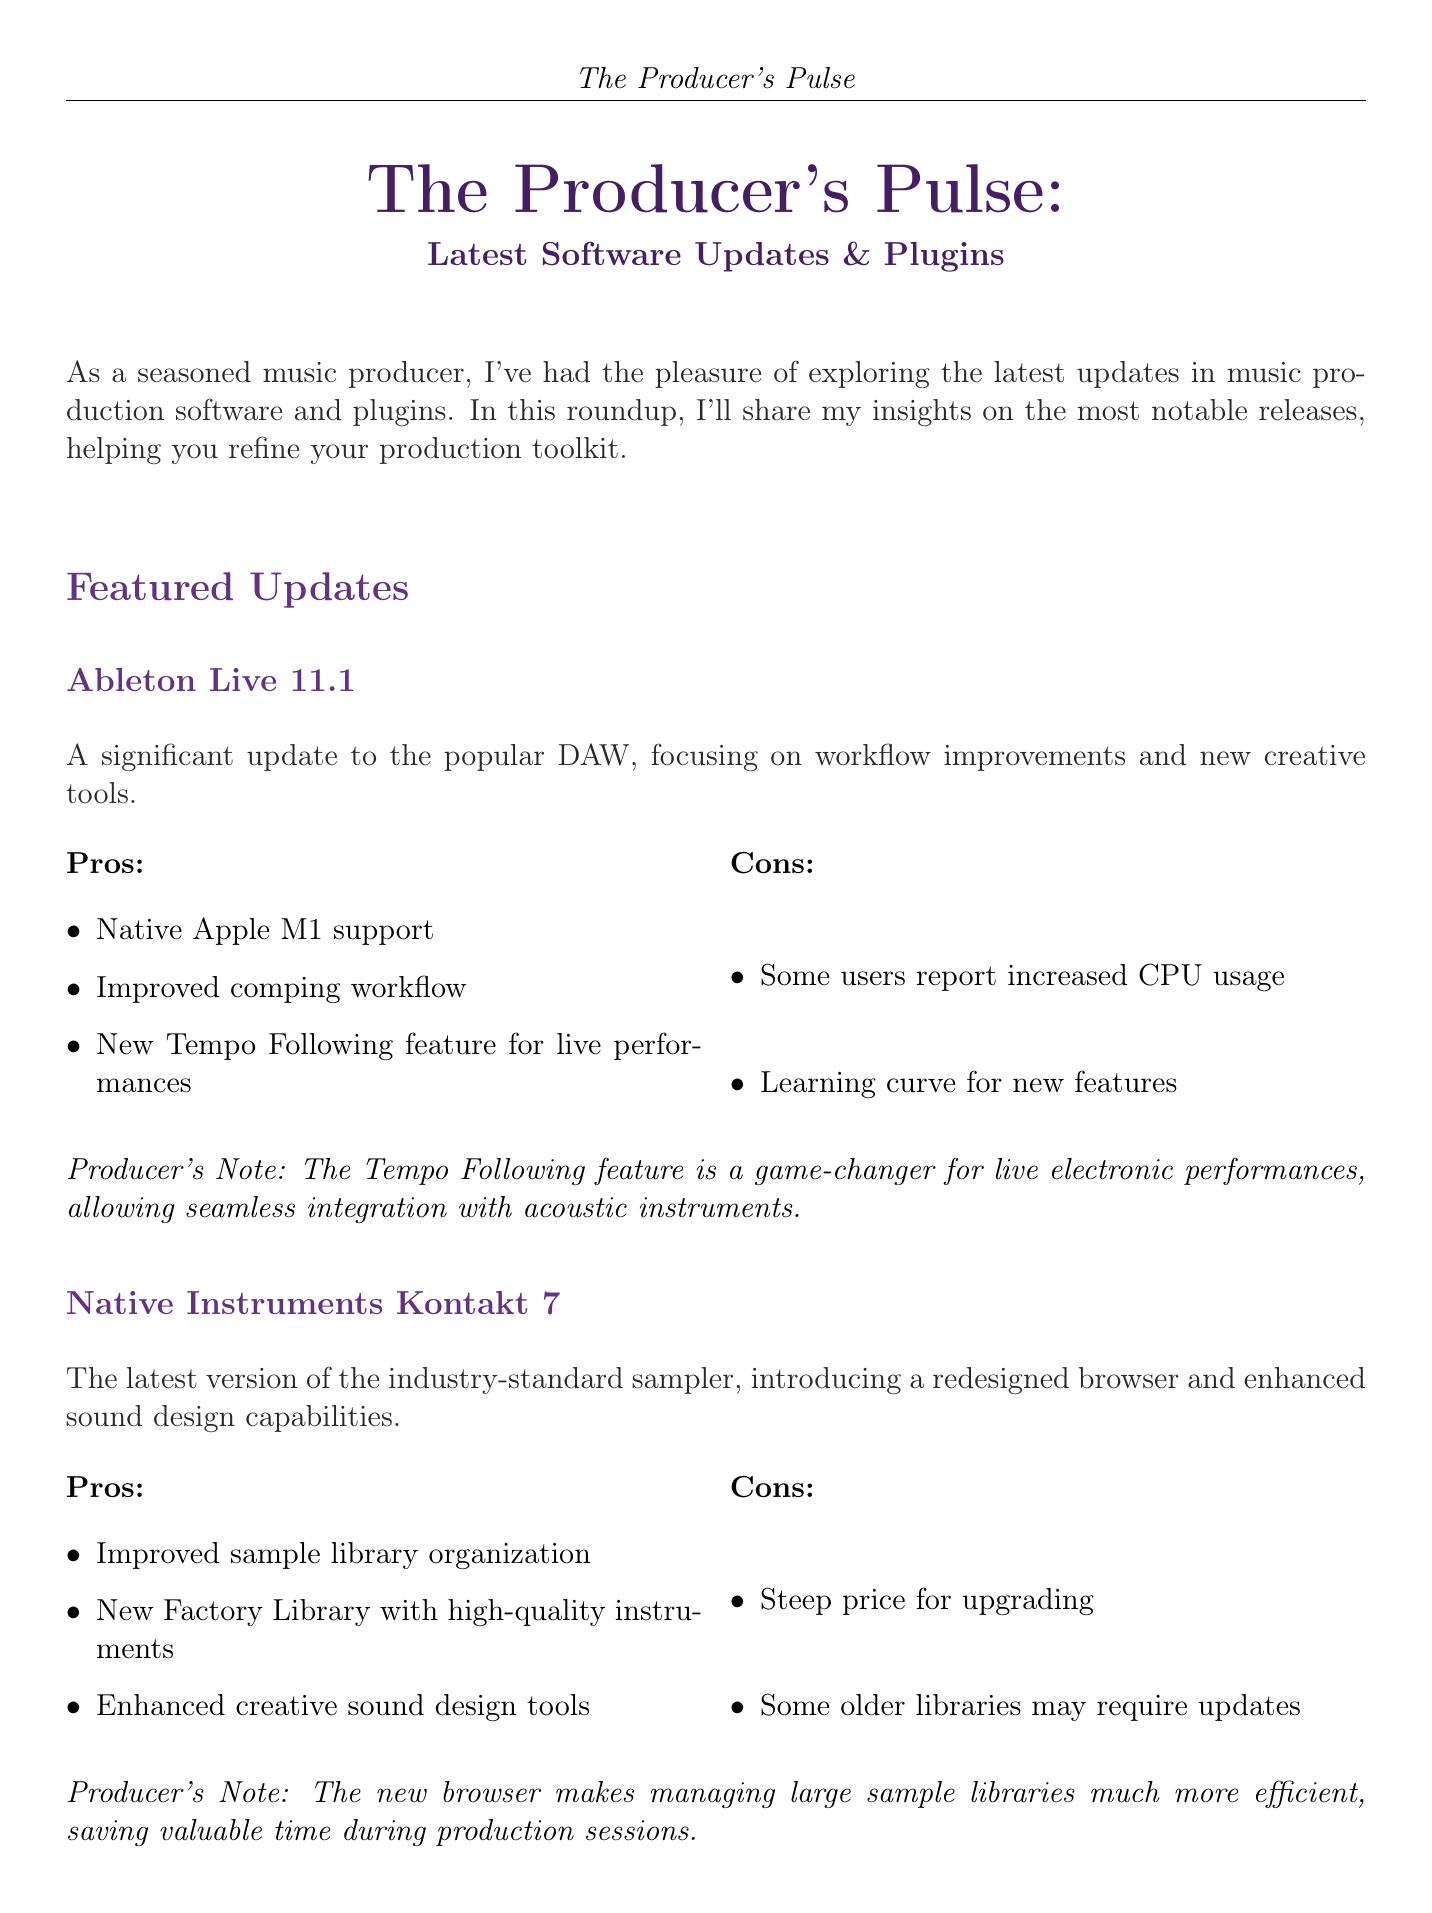What is the title of the newsletter? The title is prominently displayed at the beginning of the document.
Answer: The Producer's Pulse: Latest Software Updates & Plugins How many featured updates are there? Each featured update is distinct and is listed separately in the document.
Answer: 2 What is a notable new feature in Ableton Live 11.1? This is specific information highlighted in the update description.
Answer: Tempo Following feature What is the main benefit of Valhalla SuperMassive? The document highlights the strengths of this budget-friendly option.
Answer: Exceptional sound quality What is a con of iZotope RX 9? Cons are listed in a specific section for each tool in the document.
Answer: Significant learning curve for advanced features What type of plugin is FabFilter Pro-Q 3? The description clarifies the category and purpose of the plugin.
Answer: Equalizer plugin What does the Producer's Note emphasize about Native Instruments Kontakt 7? Producer's Notes add personal insights on each tool and highlight efficiency improvements.
Answer: Managing large sample libraries Which software supports Native Apple M1? The specific software feature is mentioned in the pros section.
Answer: Ableton Live 11.1 